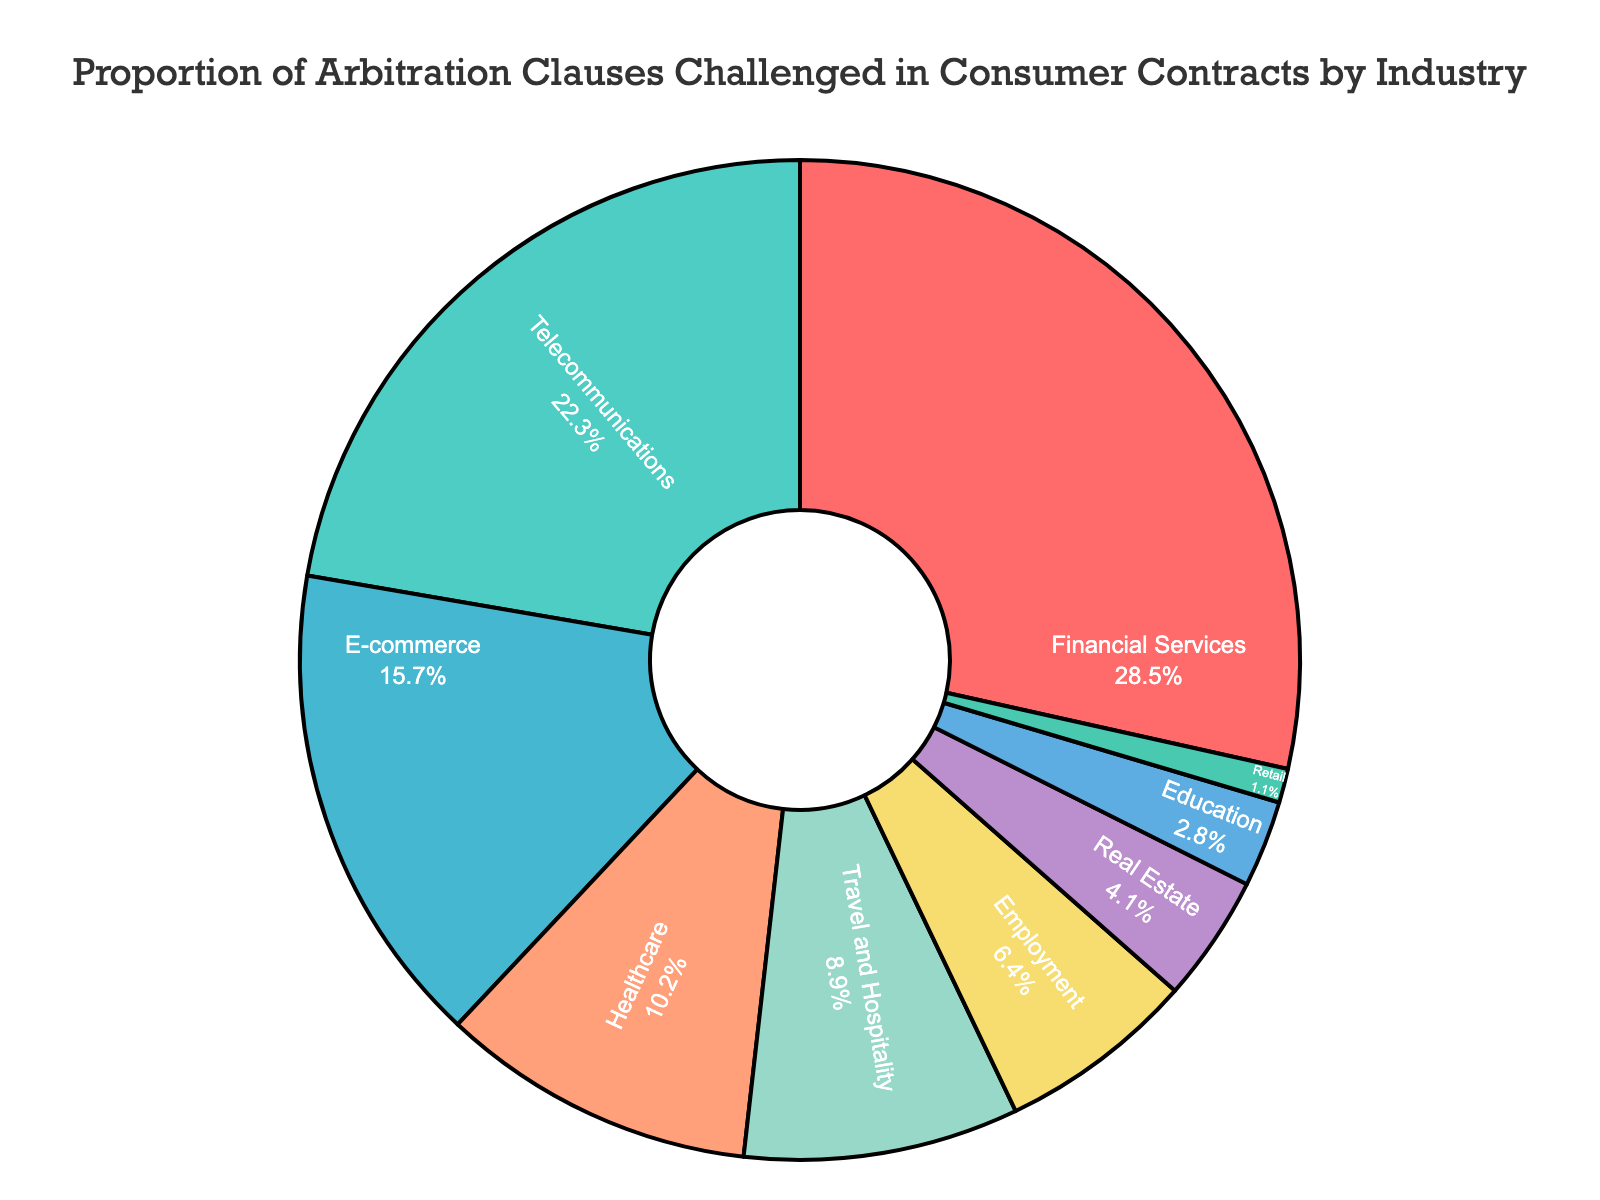Which industry has the highest proportion of arbitration clauses challenged in consumer contracts? The segment representing the highest proportion is Financial Services. According to the figure, it shows 28.5%.
Answer: Financial Services What is the combined proportion of arbitration clauses challenged in the Telecommunications and E-commerce sectors? The proportion for Telecommunications is 22.3% and for E-commerce is 15.7%. Adding these together gives 22.3% + 15.7% = 38.0%.
Answer: 38.0% Is the proportion of arbitration clauses challenged in the Healthcare sector higher than in the Travel and Hospitality sector? The proportion for Healthcare is 10.2%, while for Travel and Hospitality, it is 8.9%. Since 10.2% is greater than 8.9%, Healthcare's proportion is higher.
Answer: Yes What is the difference in the proportion between the highest and the lowest industry sectors? Financial Services has the highest proportion at 28.5%, and Retail has the lowest at 1.1%. The difference is 28.5% - 1.1% = 27.4%.
Answer: 27.4% Which sectors have a proportion of challenged arbitration clauses below 5%? The sectors with proportions below 5% are Real Estate (4.1%), Education (2.8%), and Retail (1.1%), as indicated by their respective segments in the pie chart.
Answer: Real Estate, Education, Retail What is the average proportion of arbitration clauses challenged for the Telecommunications, Healthcare, and Employment sectors? The proportions are 22.3% (Telecommunications), 10.2% (Healthcare), and 6.4% (Employment). The average is (22.3 + 10.2 + 6.4) / 3 = 12.97%.
Answer: 12.97% How does the proportion of arbitration clauses challenged in Education compare to Employment? The Education sector has a proportion of 2.8%, while the Employment sector has 6.4%. Since 2.8% < 6.4%, Education's proportion is less than Employment's.
Answer: Less What proportion of arbitration clauses are challenged in the Real Estate sector? The segment for Real Estate shows a proportion of 4.1%, as indicated by the pie chart.
Answer: 4.1% Are there more arbitration clauses challenged in E-commerce or in Real Estate? The E-commerce sector has a proportion of 15.7%, while the Real Estate sector has 4.1%. Since 15.7% > 4.1%, there are more arbitration clauses challenged in E-commerce.
Answer: E-commerce What's the total proportion for the Financial Services, Telecommunications, and Healthcare sectors combined? The proportions are Financial Services (28.5%), Telecommunications (22.3%), and Healthcare (10.2%). Adding them together gives 28.5% + 22.3% + 10.2% = 61.0%.
Answer: 61.0% 